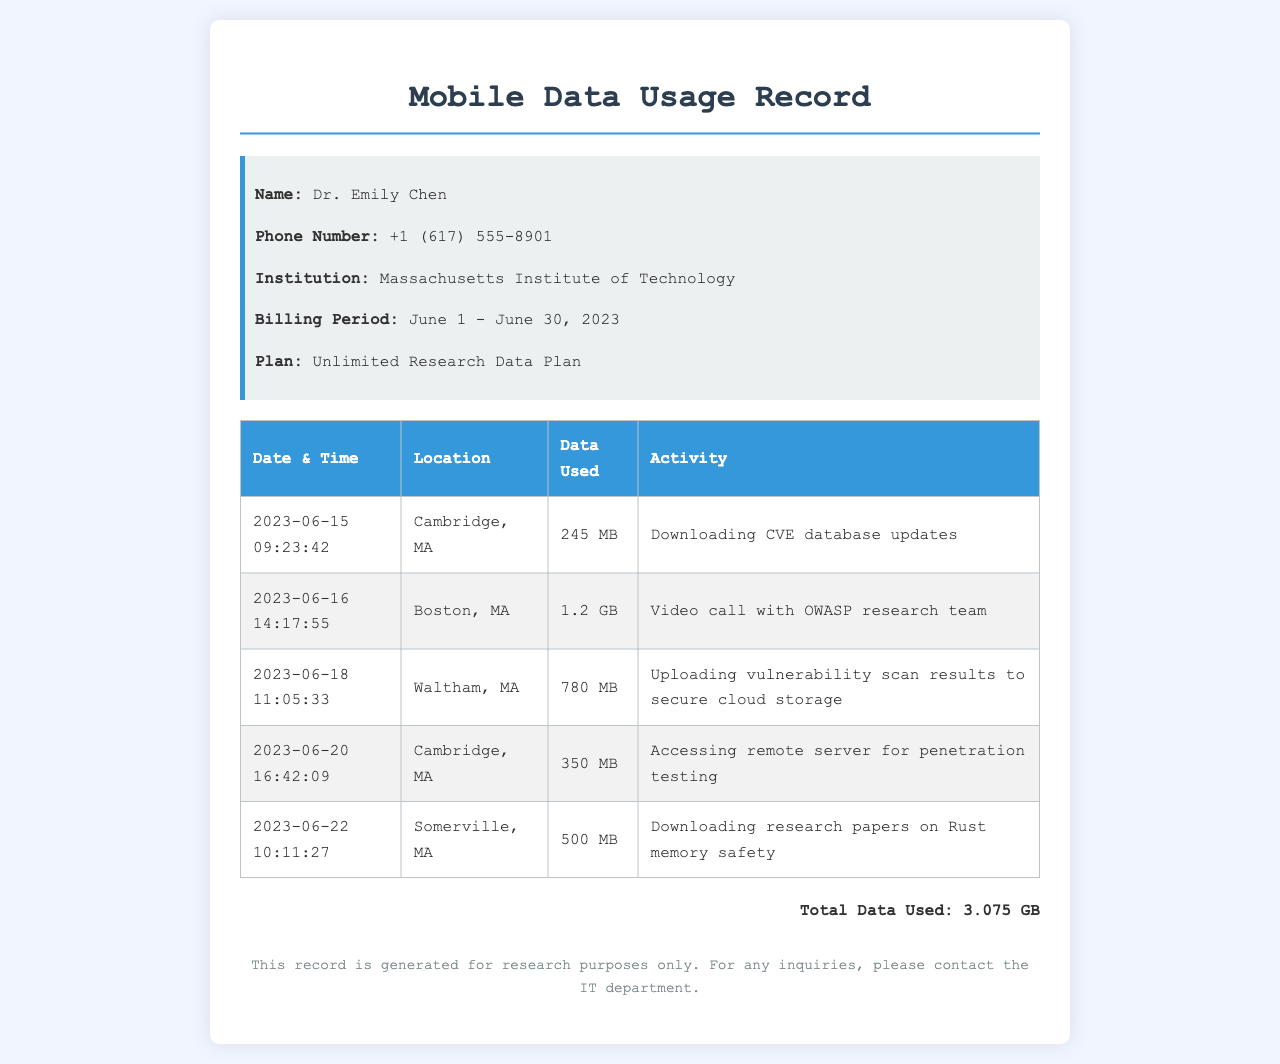what is the name of the researcher? The name of the researcher is provided in the info section of the document.
Answer: Dr. Emily Chen what is the total data usage recorded? The total data usage is calculated from the sum of the data used for each recorded activity.
Answer: 3.075 GB how much data was used during the video call? The data usage for the video call activity can be found in the corresponding row of the table.
Answer: 1.2 GB which location was visited on June 18, 2023? The specific location for the activity on June 18 is listed in the table next to the date and time.
Answer: Waltham, MA what type of plan does Dr. Emily Chen have? The type of plan can be found in the info section of the document.
Answer: Unlimited Research Data Plan how many megabytes were used to access the remote server for penetration testing? The data used for the penetration testing activity is specified in the table.
Answer: 350 MB which research topic was explored on June 22, 2023? The topic of research is mentioned in the activity column of the table for that date.
Answer: Rust memory safety what date and time was the download of CVE database updates? The specific date and time for the CVE database updates can be found in the table.
Answer: 2023-06-15 09:23:42 which institution is Dr. Emily Chen affiliated with? The institution name is provided in the info section of the document.
Answer: Massachusetts Institute of Technology 